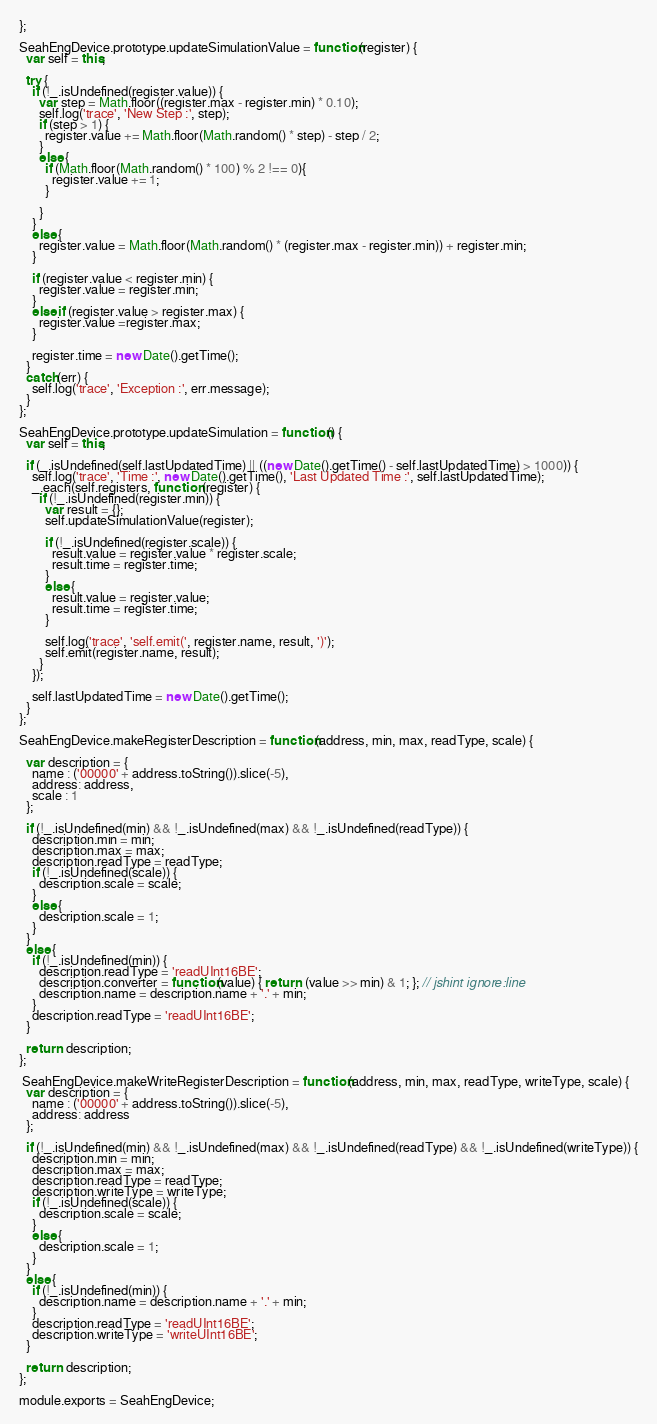<code> <loc_0><loc_0><loc_500><loc_500><_JavaScript_>};

SeahEngDevice.prototype.updateSimulationValue = function(register) {
  var self = this;

  try {
    if (!_.isUndefined(register.value)) {
      var step = Math.floor((register.max - register.min) * 0.10);
      self.log('trace', 'New Step :', step);
      if (step > 1) {
        register.value += Math.floor(Math.random() * step) - step / 2;
      }
      else {
        if (Math.floor(Math.random() * 100) % 2 !== 0){
          register.value += 1;
        }
  
      }
    }
    else {
      register.value = Math.floor(Math.random() * (register.max - register.min)) + register.min;
    }

    if (register.value < register.min) {
      register.value = register.min;
    }
    else if (register.value > register.max) {
      register.value =register.max;
    }
  
    register.time = new Date().getTime();
  }
  catch(err) {
    self.log('trace', 'Exception :', err.message);
  }
};

SeahEngDevice.prototype.updateSimulation = function() {
  var self = this;

  if (_.isUndefined(self.lastUpdatedTime) || ((new Date().getTime() - self.lastUpdatedTime) > 1000)) {
    self.log('trace', 'Time :', new Date().getTime(), 'Last Updated Time :', self.lastUpdatedTime);
    _.each(self.registers, function (register) {
      if (!_.isUndefined(register.min)) {
        var result = {};
        self.updateSimulationValue(register);

        if (!_.isUndefined(register.scale)) {
          result.value = register.value * register.scale;
          result.time = register.time;
        }
        else {
          result.value = register.value;
          result.time = register.time;
        }

        self.log('trace', 'self.emit(', register.name, result, ')');
        self.emit(register.name, result);
      }
    });

    self.lastUpdatedTime = new Date().getTime();
  }
};

SeahEngDevice.makeRegisterDescription = function(address, min, max, readType, scale) {
  
  var description = {
    name : ('00000' + address.toString()).slice(-5),
    address: address,
    scale : 1
  };

  if (!_.isUndefined(min) && !_.isUndefined(max) && !_.isUndefined(readType)) {
    description.min = min;
    description.max = max;
    description.readType = readType;
    if (!_.isUndefined(scale)) { 
      description.scale = scale;
    }
    else {
      description.scale = 1;
    }
  }
  else {
    if (!_.isUndefined(min)) {
      description.readType = 'readUInt16BE';
      description.converter = function(value) { return  (value >> min) & 1; }; // jshint ignore:line
      description.name = description.name + '.' + min;
    }
    description.readType = 'readUInt16BE';
  }

  return  description;
};

 SeahEngDevice.makeWriteRegisterDescription = function(address, min, max, readType, writeType, scale) {
  var description = {
    name : ('00000' + address.toString()).slice(-5),
    address: address
  };

  if (!_.isUndefined(min) && !_.isUndefined(max) && !_.isUndefined(readType) && !_.isUndefined(writeType)) {
    description.min = min;
    description.max = max;
    description.readType = readType;
    description.writeType = writeType;
    if (!_.isUndefined(scale)) { 
      description.scale = scale;
    }
    else {
      description.scale = 1;
    }
  }
  else {
    if (!_.isUndefined(min)) {
      description.name = description.name + '.' + min;
    }
    description.readType = 'readUInt16BE';
    description.writeType = 'writeUInt16BE';
  }

  return  description;
};

module.exports = SeahEngDevice;</code> 